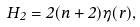Convert formula to latex. <formula><loc_0><loc_0><loc_500><loc_500>\dot { H } _ { 2 } = 2 ( n + 2 ) \eta ( r ) ,</formula> 